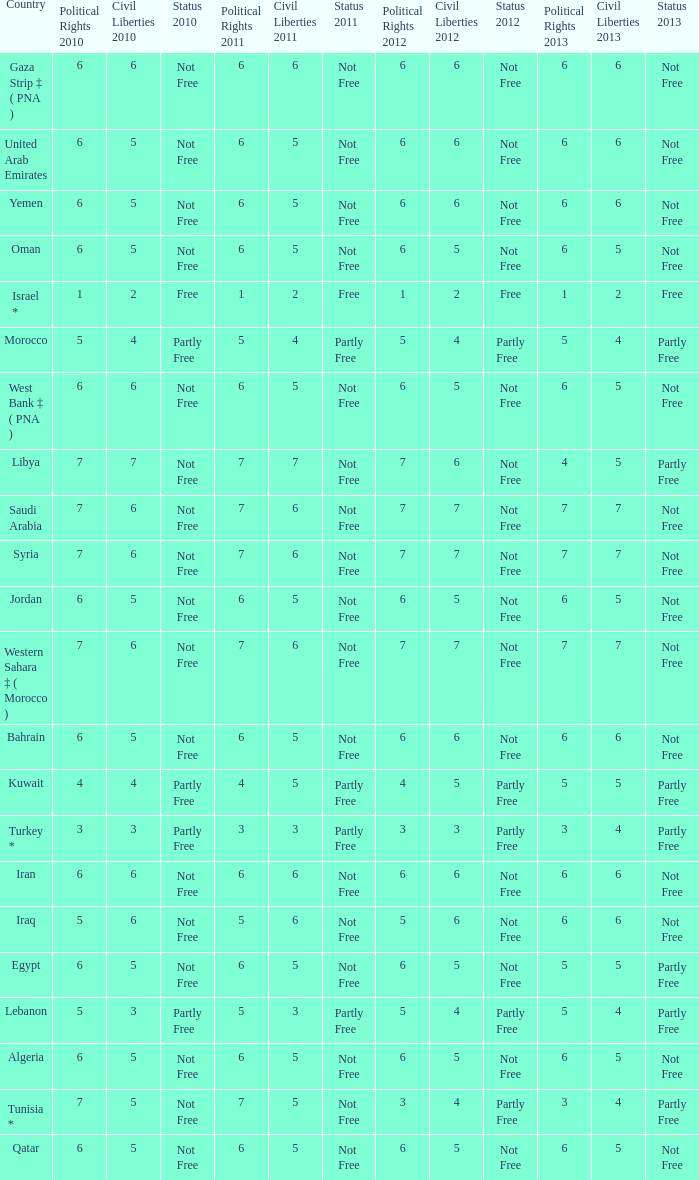How many civil liberties 2013 values are associated with a 2010 political rights value of 6, civil liberties 2012 values over 5, and political rights 2011 under 6? 0.0. 